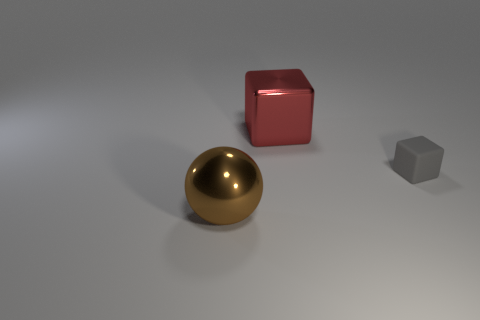Is there any other thing that is the same material as the gray block?
Offer a terse response. No. There is a shiny sphere that is the same size as the metal block; what is its color?
Offer a very short reply. Brown. Are the large thing behind the brown ball and the sphere made of the same material?
Make the answer very short. Yes. There is a big metal object that is in front of the cube that is to the right of the large block; are there any gray matte things that are in front of it?
Keep it short and to the point. No. Do the big object to the left of the big block and the gray thing have the same shape?
Provide a short and direct response. No. There is a metal object in front of the big thing behind the ball; what shape is it?
Give a very brief answer. Sphere. There is a block that is right of the big object that is to the right of the large thing on the left side of the big red shiny cube; what is its size?
Ensure brevity in your answer.  Small. What is the color of the small thing that is the same shape as the large red thing?
Make the answer very short. Gray. Is the size of the red metallic block the same as the brown metallic thing?
Offer a very short reply. Yes. What material is the large object that is on the right side of the big brown metal ball?
Make the answer very short. Metal. 